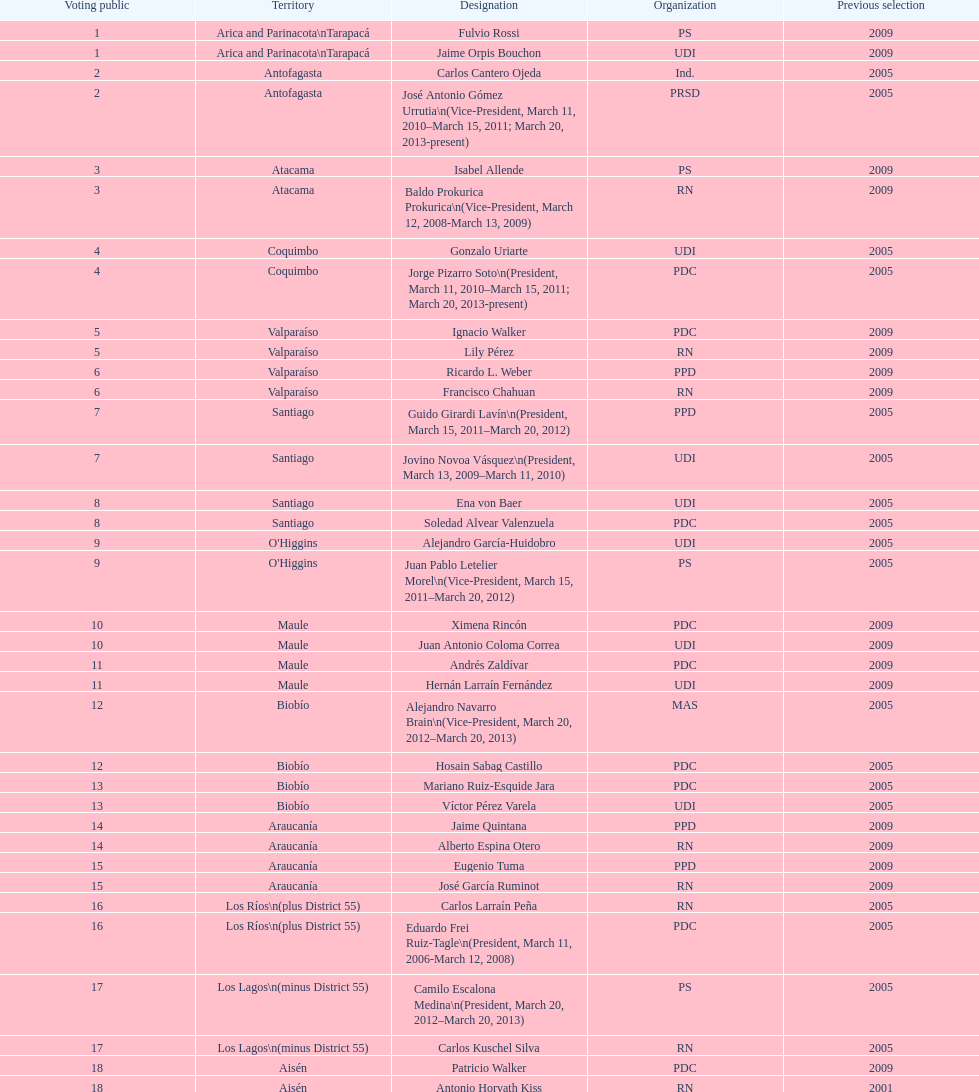How many total consituency are listed in the table? 19. 